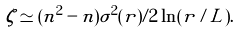Convert formula to latex. <formula><loc_0><loc_0><loc_500><loc_500>\zeta \simeq ( n ^ { 2 } - n ) \sigma ^ { 2 } ( r ) / 2 \ln ( r / L ) .</formula> 